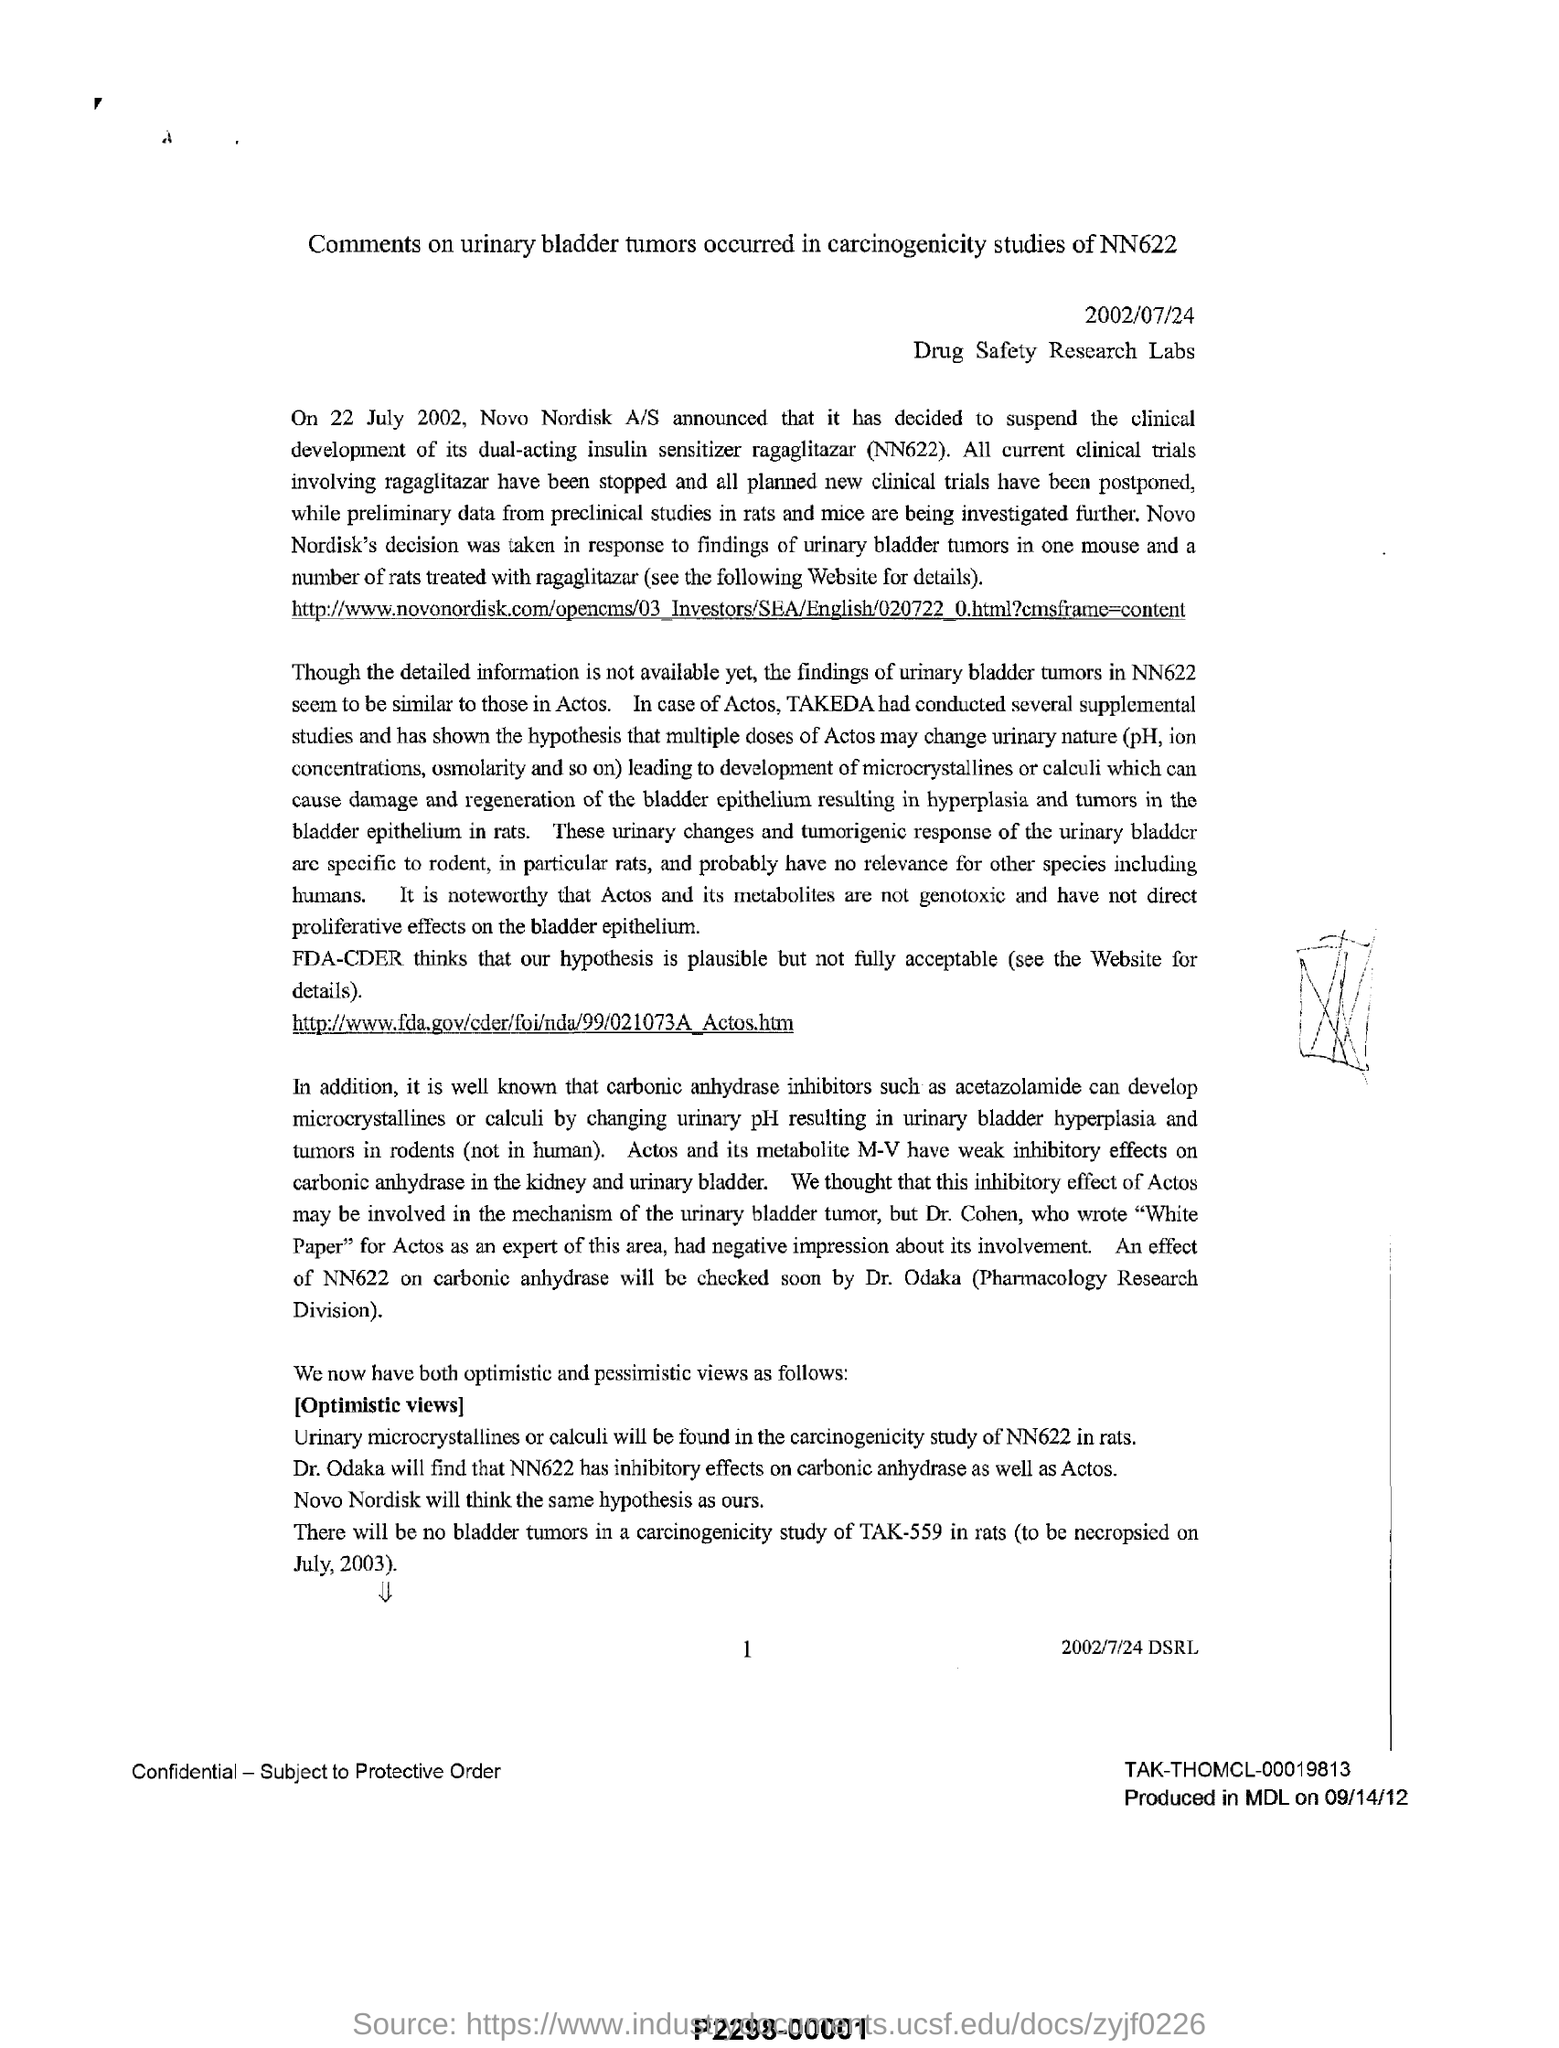Draw attention to some important aspects in this diagram. On July 22, 2002, Novo Nordisk A/S announced its decision to suspend the clinical development of its dual-acting insulin sensitizer, ragaglitazar (NN622). The production location is MDL. The date on the document is 2002/07/24. On September 14, 2012, the product was produced. The results of the carcinogenicity study of NN622 in rats will reveal the presence of urinary microcrystallines or calculi. 